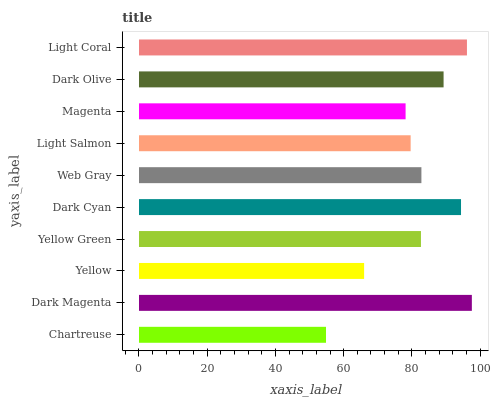Is Chartreuse the minimum?
Answer yes or no. Yes. Is Dark Magenta the maximum?
Answer yes or no. Yes. Is Yellow the minimum?
Answer yes or no. No. Is Yellow the maximum?
Answer yes or no. No. Is Dark Magenta greater than Yellow?
Answer yes or no. Yes. Is Yellow less than Dark Magenta?
Answer yes or no. Yes. Is Yellow greater than Dark Magenta?
Answer yes or no. No. Is Dark Magenta less than Yellow?
Answer yes or no. No. Is Web Gray the high median?
Answer yes or no. Yes. Is Yellow Green the low median?
Answer yes or no. Yes. Is Chartreuse the high median?
Answer yes or no. No. Is Dark Cyan the low median?
Answer yes or no. No. 